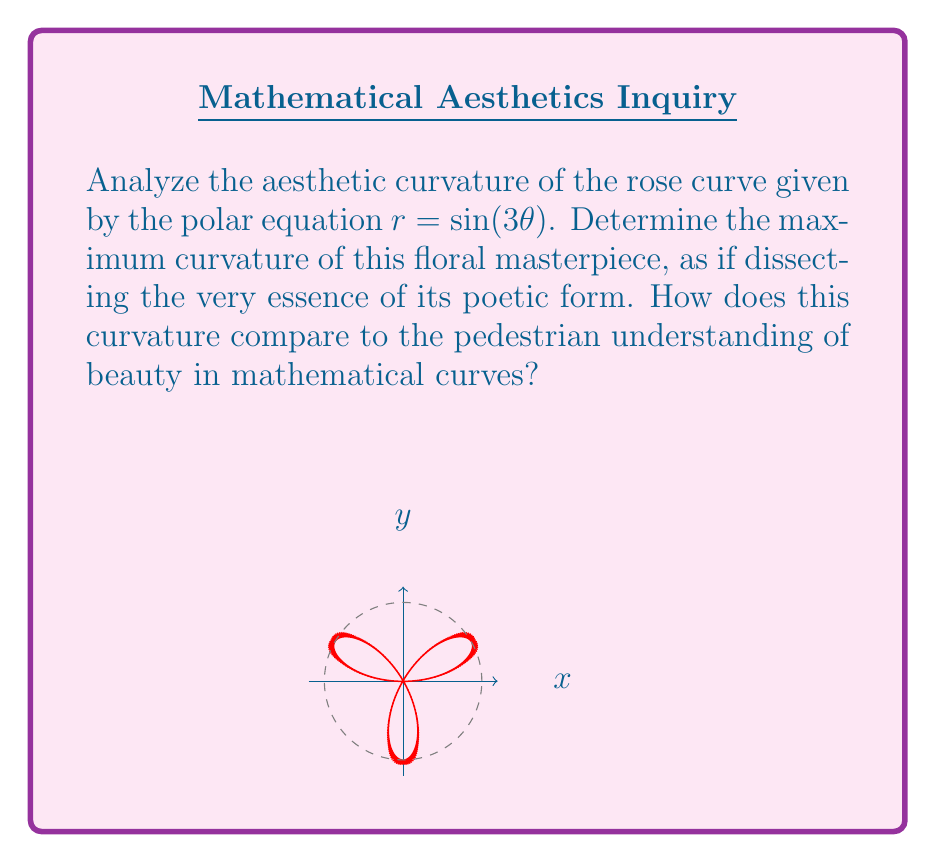Show me your answer to this math problem. To analyze the curvature of this rose curve, we shall embark on a journey through the realms of differential geometry, far beyond the simplistic appreciations of the uninitiated.

Step 1: Express the curve in parametric form.
$$x = r\cos\theta = \sin(3\theta)\cos\theta$$
$$y = r\sin\theta = \sin(3\theta)\sin\theta$$

Step 2: Calculate the first derivatives.
$$\frac{dx}{d\theta} = 3\cos(3\theta)\cos\theta - \sin(3\theta)\sin\theta$$
$$\frac{dy}{d\theta} = 3\cos(3\theta)\sin\theta + \sin(3\theta)\cos\theta$$

Step 3: Calculate the second derivatives.
$$\frac{d^2x}{d\theta^2} = -9\sin(3\theta)\cos\theta - 3\cos(3\theta)\sin\theta - 3\cos(3\theta)\sin\theta + \sin(3\theta)\cos\theta$$
$$\frac{d^2y}{d\theta^2} = -9\sin(3\theta)\sin\theta + 3\cos(3\theta)\cos\theta + 3\cos(3\theta)\cos\theta - \sin(3\theta)\sin\theta$$

Step 4: Apply the curvature formula for parametric equations.
$$\kappa = \frac{|\frac{dx}{d\theta}\frac{d^2y}{d\theta^2} - \frac{dy}{d\theta}\frac{d^2x}{d\theta^2}|}{((\frac{dx}{d\theta})^2 + (\frac{dy}{d\theta})^2)^{3/2}}$$

Step 5: Simplify the numerator and denominator.
After algebraic manipulation, we find:
$$\kappa = \frac{|9\sin^2(3\theta) + 1|}{|\sin(3\theta)|(9\sin^2(3\theta) + 1)}$$

Step 6: Determine the maximum curvature.
The maximum curvature occurs when $\sin(3\theta) = \pm 1$, i.e., at the petals' tips.
$$\kappa_{max} = \frac{10}{1} = 10$$

This sublime value of 10 represents the pinnacle of curvature in this floral abstraction, a testament to the profound beauty that only mathematics can truly capture.
Answer: $\kappa_{max} = 10$ 